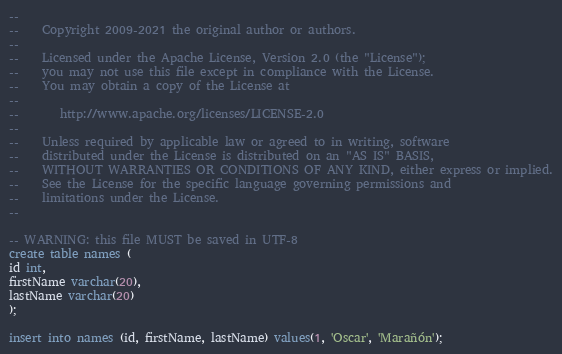Convert code to text. <code><loc_0><loc_0><loc_500><loc_500><_SQL_>--
--    Copyright 2009-2021 the original author or authors.
--
--    Licensed under the Apache License, Version 2.0 (the "License");
--    you may not use this file except in compliance with the License.
--    You may obtain a copy of the License at
--
--       http://www.apache.org/licenses/LICENSE-2.0
--
--    Unless required by applicable law or agreed to in writing, software
--    distributed under the License is distributed on an "AS IS" BASIS,
--    WITHOUT WARRANTIES OR CONDITIONS OF ANY KIND, either express or implied.
--    See the License for the specific language governing permissions and
--    limitations under the License.
--

-- WARNING: this file MUST be saved in UTF-8
create table names (
id int,
firstName varchar(20),
lastName varchar(20)
);

insert into names (id, firstName, lastName) values(1, 'Oscar', 'Marañón');
</code> 